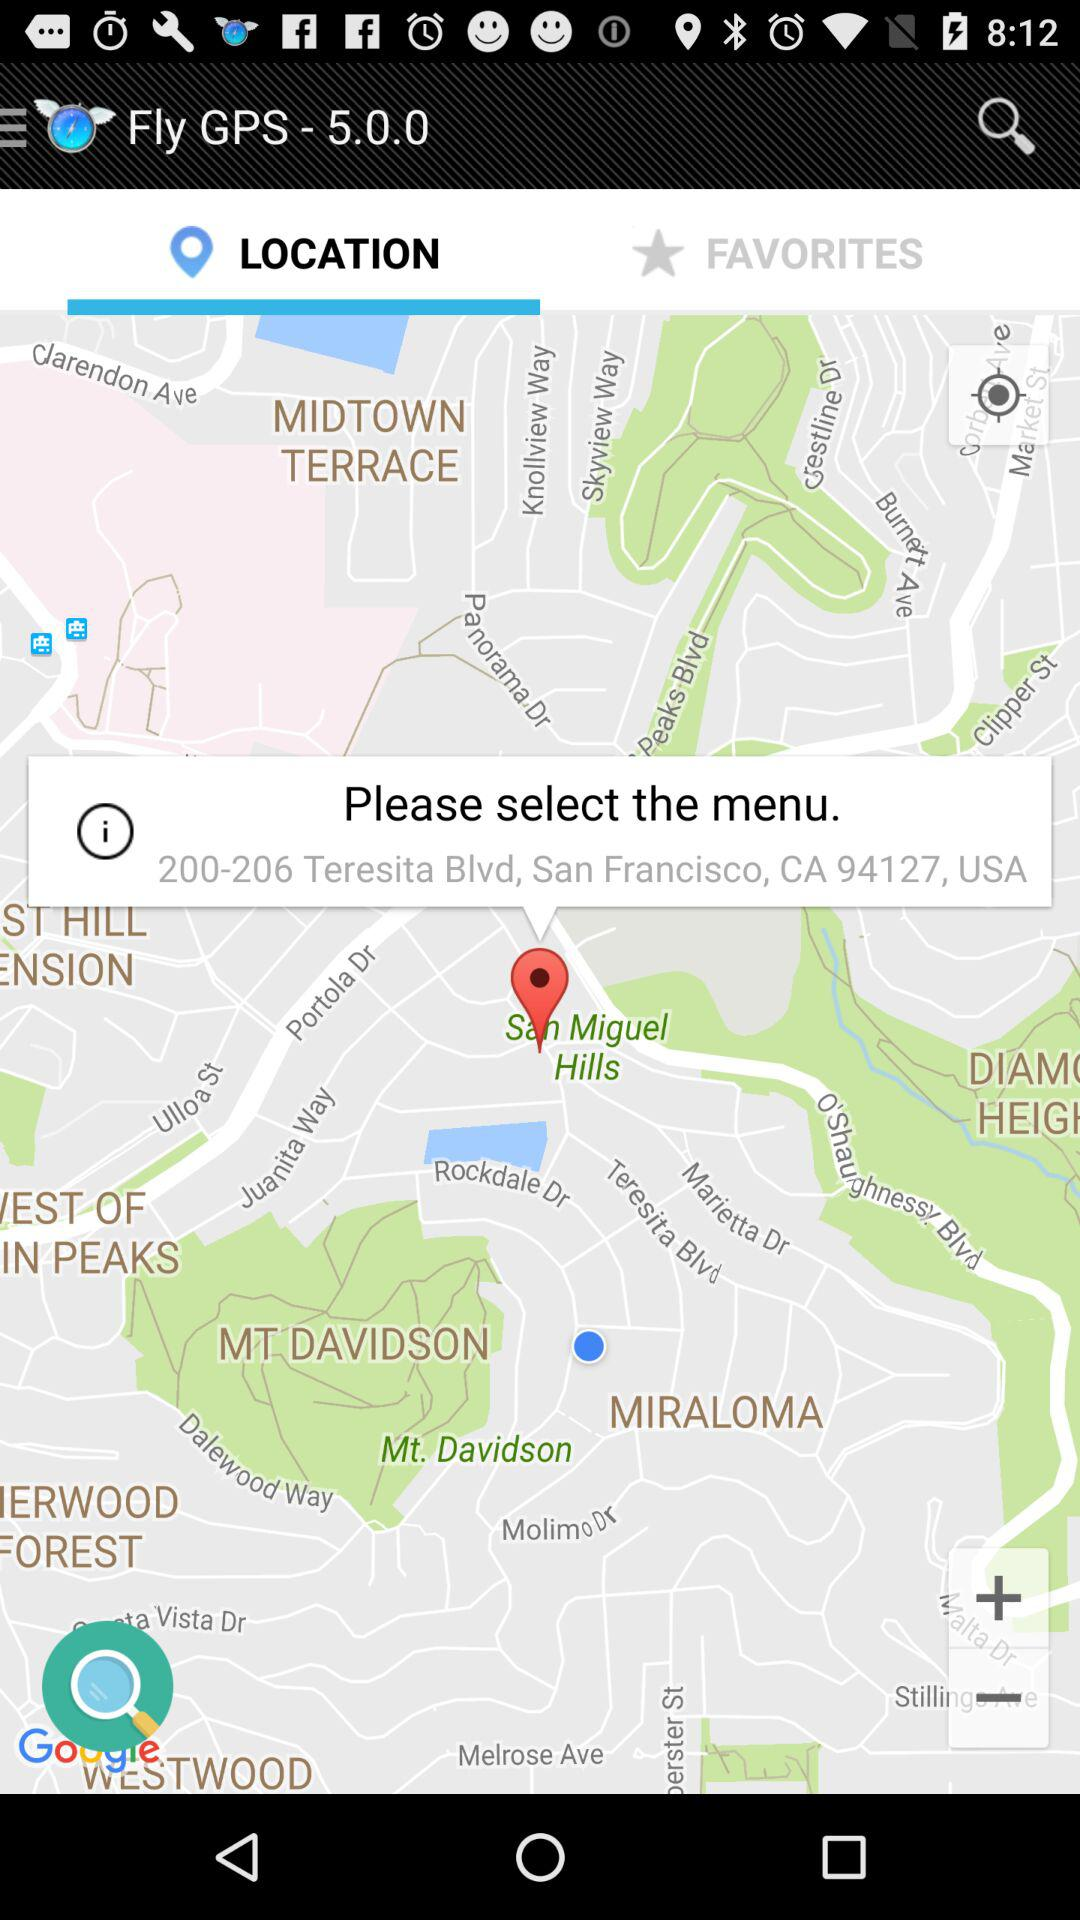Which tab am I using? You are using "LOCATION" tab. 